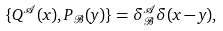Convert formula to latex. <formula><loc_0><loc_0><loc_500><loc_500>\{ Q ^ { \mathcal { A } } ( x ) , P _ { \mathcal { B } } ( y ) \} = \delta ^ { \mathcal { A } } _ { \mathcal { B } } \delta ( x - y ) ,</formula> 